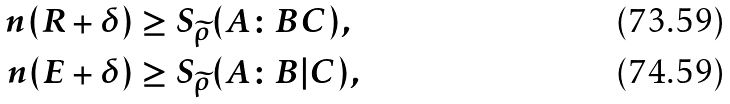<formula> <loc_0><loc_0><loc_500><loc_500>n ( R + \delta ) & \geq S _ { \widetilde { \rho } } ( A \colon B C ) , \\ n ( E + \delta ) & \geq S _ { \widetilde { \rho } } ( A \colon B | C ) ,</formula> 